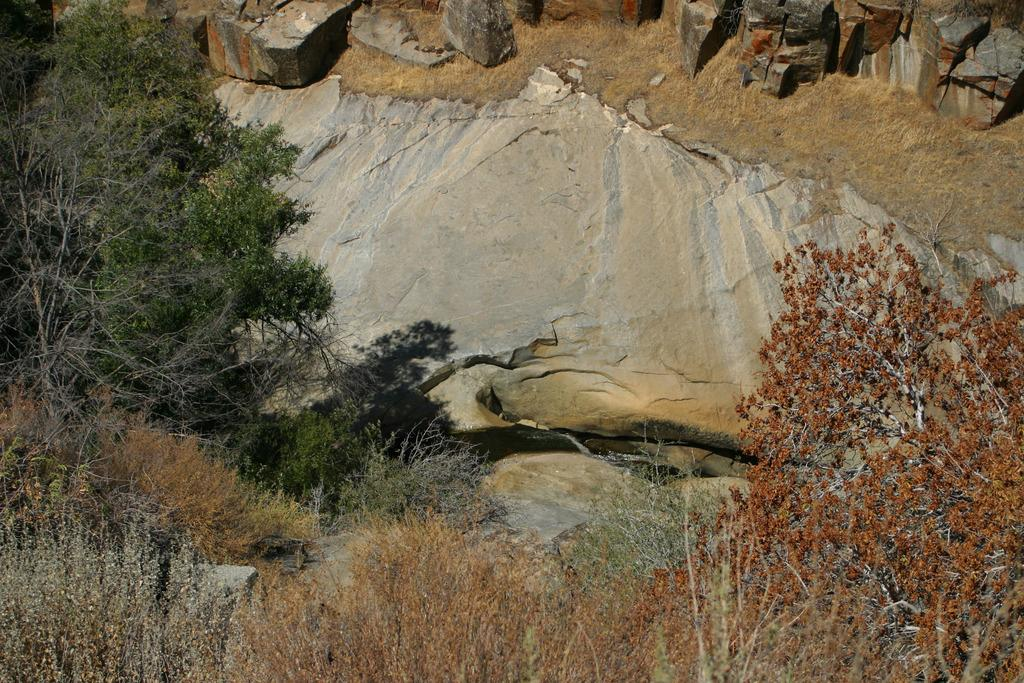What type of vegetation can be seen in the image? There are plants and trees visible in the image. What natural element is present in the image? There is water visible in the image. What geological feature can be seen in the image? There are rocks visible in the image. What type of horn can be seen on the plants in the image? There are no horns present on the plants in the image. How many trucks are visible in the image? There are no trucks visible in the image. 